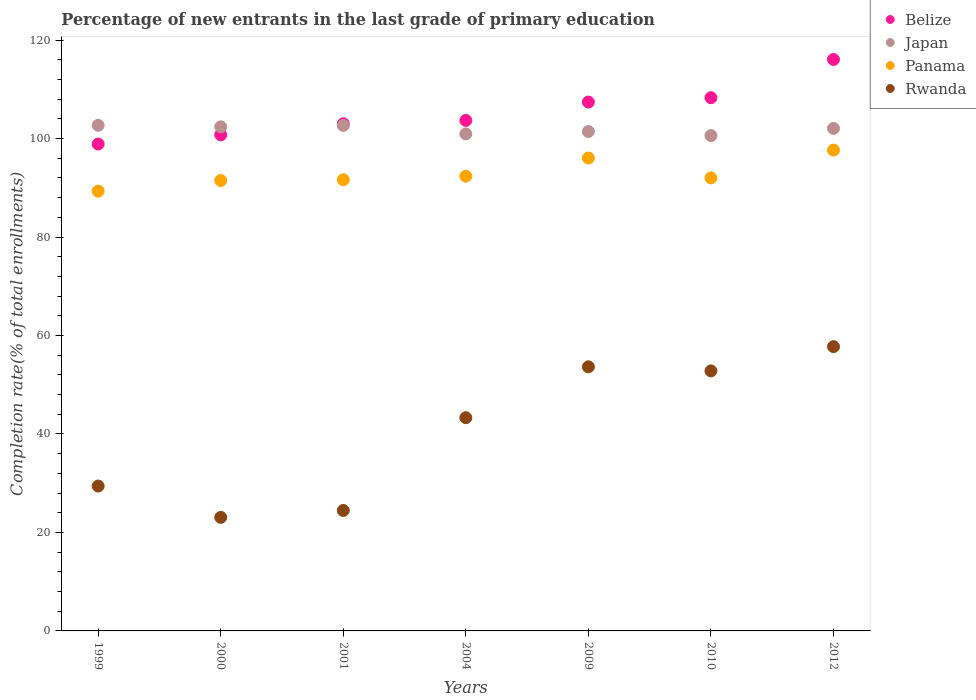What is the percentage of new entrants in Belize in 2009?
Your response must be concise. 107.41. Across all years, what is the maximum percentage of new entrants in Rwanda?
Your response must be concise. 57.74. Across all years, what is the minimum percentage of new entrants in Belize?
Provide a succinct answer. 98.88. In which year was the percentage of new entrants in Rwanda maximum?
Your answer should be compact. 2012. What is the total percentage of new entrants in Rwanda in the graph?
Keep it short and to the point. 284.45. What is the difference between the percentage of new entrants in Rwanda in 1999 and that in 2009?
Give a very brief answer. -24.21. What is the difference between the percentage of new entrants in Panama in 2009 and the percentage of new entrants in Rwanda in 2010?
Give a very brief answer. 43.23. What is the average percentage of new entrants in Rwanda per year?
Ensure brevity in your answer.  40.64. In the year 1999, what is the difference between the percentage of new entrants in Rwanda and percentage of new entrants in Belize?
Your answer should be very brief. -69.46. What is the ratio of the percentage of new entrants in Rwanda in 2000 to that in 2009?
Ensure brevity in your answer.  0.43. Is the difference between the percentage of new entrants in Rwanda in 1999 and 2012 greater than the difference between the percentage of new entrants in Belize in 1999 and 2012?
Make the answer very short. No. What is the difference between the highest and the second highest percentage of new entrants in Belize?
Provide a succinct answer. 7.76. What is the difference between the highest and the lowest percentage of new entrants in Panama?
Provide a succinct answer. 8.34. Is the percentage of new entrants in Rwanda strictly greater than the percentage of new entrants in Belize over the years?
Offer a terse response. No. Are the values on the major ticks of Y-axis written in scientific E-notation?
Ensure brevity in your answer.  No. How many legend labels are there?
Your response must be concise. 4. What is the title of the graph?
Ensure brevity in your answer.  Percentage of new entrants in the last grade of primary education. Does "Morocco" appear as one of the legend labels in the graph?
Your response must be concise. No. What is the label or title of the Y-axis?
Your answer should be very brief. Completion rate(% of total enrollments). What is the Completion rate(% of total enrollments) of Belize in 1999?
Ensure brevity in your answer.  98.88. What is the Completion rate(% of total enrollments) of Japan in 1999?
Ensure brevity in your answer.  102.69. What is the Completion rate(% of total enrollments) in Panama in 1999?
Ensure brevity in your answer.  89.32. What is the Completion rate(% of total enrollments) of Rwanda in 1999?
Offer a terse response. 29.43. What is the Completion rate(% of total enrollments) of Belize in 2000?
Ensure brevity in your answer.  100.76. What is the Completion rate(% of total enrollments) of Japan in 2000?
Your response must be concise. 102.38. What is the Completion rate(% of total enrollments) in Panama in 2000?
Your answer should be compact. 91.48. What is the Completion rate(% of total enrollments) in Rwanda in 2000?
Provide a succinct answer. 23.06. What is the Completion rate(% of total enrollments) of Belize in 2001?
Ensure brevity in your answer.  103. What is the Completion rate(% of total enrollments) in Japan in 2001?
Provide a short and direct response. 102.66. What is the Completion rate(% of total enrollments) in Panama in 2001?
Your answer should be compact. 91.63. What is the Completion rate(% of total enrollments) of Rwanda in 2001?
Provide a short and direct response. 24.47. What is the Completion rate(% of total enrollments) in Belize in 2004?
Offer a very short reply. 103.68. What is the Completion rate(% of total enrollments) of Japan in 2004?
Your answer should be compact. 100.95. What is the Completion rate(% of total enrollments) in Panama in 2004?
Provide a short and direct response. 92.35. What is the Completion rate(% of total enrollments) in Rwanda in 2004?
Your response must be concise. 43.31. What is the Completion rate(% of total enrollments) of Belize in 2009?
Offer a terse response. 107.41. What is the Completion rate(% of total enrollments) of Japan in 2009?
Your answer should be compact. 101.44. What is the Completion rate(% of total enrollments) of Panama in 2009?
Offer a terse response. 96.04. What is the Completion rate(% of total enrollments) of Rwanda in 2009?
Ensure brevity in your answer.  53.64. What is the Completion rate(% of total enrollments) in Belize in 2010?
Ensure brevity in your answer.  108.3. What is the Completion rate(% of total enrollments) of Japan in 2010?
Make the answer very short. 100.6. What is the Completion rate(% of total enrollments) of Panama in 2010?
Provide a short and direct response. 92.01. What is the Completion rate(% of total enrollments) in Rwanda in 2010?
Offer a terse response. 52.81. What is the Completion rate(% of total enrollments) in Belize in 2012?
Keep it short and to the point. 116.06. What is the Completion rate(% of total enrollments) in Japan in 2012?
Provide a succinct answer. 102.06. What is the Completion rate(% of total enrollments) of Panama in 2012?
Provide a succinct answer. 97.66. What is the Completion rate(% of total enrollments) in Rwanda in 2012?
Your answer should be compact. 57.74. Across all years, what is the maximum Completion rate(% of total enrollments) of Belize?
Make the answer very short. 116.06. Across all years, what is the maximum Completion rate(% of total enrollments) of Japan?
Ensure brevity in your answer.  102.69. Across all years, what is the maximum Completion rate(% of total enrollments) of Panama?
Your response must be concise. 97.66. Across all years, what is the maximum Completion rate(% of total enrollments) in Rwanda?
Offer a terse response. 57.74. Across all years, what is the minimum Completion rate(% of total enrollments) of Belize?
Keep it short and to the point. 98.88. Across all years, what is the minimum Completion rate(% of total enrollments) of Japan?
Your response must be concise. 100.6. Across all years, what is the minimum Completion rate(% of total enrollments) in Panama?
Make the answer very short. 89.32. Across all years, what is the minimum Completion rate(% of total enrollments) of Rwanda?
Keep it short and to the point. 23.06. What is the total Completion rate(% of total enrollments) in Belize in the graph?
Offer a very short reply. 738.09. What is the total Completion rate(% of total enrollments) of Japan in the graph?
Give a very brief answer. 712.76. What is the total Completion rate(% of total enrollments) in Panama in the graph?
Make the answer very short. 650.49. What is the total Completion rate(% of total enrollments) of Rwanda in the graph?
Keep it short and to the point. 284.45. What is the difference between the Completion rate(% of total enrollments) in Belize in 1999 and that in 2000?
Keep it short and to the point. -1.87. What is the difference between the Completion rate(% of total enrollments) in Japan in 1999 and that in 2000?
Ensure brevity in your answer.  0.31. What is the difference between the Completion rate(% of total enrollments) of Panama in 1999 and that in 2000?
Your answer should be compact. -2.16. What is the difference between the Completion rate(% of total enrollments) in Rwanda in 1999 and that in 2000?
Offer a very short reply. 6.37. What is the difference between the Completion rate(% of total enrollments) in Belize in 1999 and that in 2001?
Keep it short and to the point. -4.11. What is the difference between the Completion rate(% of total enrollments) of Japan in 1999 and that in 2001?
Your answer should be very brief. 0.03. What is the difference between the Completion rate(% of total enrollments) in Panama in 1999 and that in 2001?
Offer a very short reply. -2.31. What is the difference between the Completion rate(% of total enrollments) in Rwanda in 1999 and that in 2001?
Make the answer very short. 4.96. What is the difference between the Completion rate(% of total enrollments) in Belize in 1999 and that in 2004?
Your response must be concise. -4.79. What is the difference between the Completion rate(% of total enrollments) of Japan in 1999 and that in 2004?
Your response must be concise. 1.74. What is the difference between the Completion rate(% of total enrollments) of Panama in 1999 and that in 2004?
Ensure brevity in your answer.  -3.03. What is the difference between the Completion rate(% of total enrollments) of Rwanda in 1999 and that in 2004?
Make the answer very short. -13.88. What is the difference between the Completion rate(% of total enrollments) in Belize in 1999 and that in 2009?
Your response must be concise. -8.53. What is the difference between the Completion rate(% of total enrollments) in Japan in 1999 and that in 2009?
Give a very brief answer. 1.25. What is the difference between the Completion rate(% of total enrollments) of Panama in 1999 and that in 2009?
Your response must be concise. -6.72. What is the difference between the Completion rate(% of total enrollments) of Rwanda in 1999 and that in 2009?
Your response must be concise. -24.21. What is the difference between the Completion rate(% of total enrollments) in Belize in 1999 and that in 2010?
Your answer should be compact. -9.41. What is the difference between the Completion rate(% of total enrollments) of Japan in 1999 and that in 2010?
Offer a very short reply. 2.09. What is the difference between the Completion rate(% of total enrollments) of Panama in 1999 and that in 2010?
Your answer should be very brief. -2.7. What is the difference between the Completion rate(% of total enrollments) of Rwanda in 1999 and that in 2010?
Make the answer very short. -23.38. What is the difference between the Completion rate(% of total enrollments) in Belize in 1999 and that in 2012?
Your answer should be compact. -17.18. What is the difference between the Completion rate(% of total enrollments) in Japan in 1999 and that in 2012?
Make the answer very short. 0.63. What is the difference between the Completion rate(% of total enrollments) in Panama in 1999 and that in 2012?
Your response must be concise. -8.34. What is the difference between the Completion rate(% of total enrollments) of Rwanda in 1999 and that in 2012?
Make the answer very short. -28.31. What is the difference between the Completion rate(% of total enrollments) of Belize in 2000 and that in 2001?
Your response must be concise. -2.24. What is the difference between the Completion rate(% of total enrollments) in Japan in 2000 and that in 2001?
Give a very brief answer. -0.28. What is the difference between the Completion rate(% of total enrollments) of Panama in 2000 and that in 2001?
Provide a short and direct response. -0.15. What is the difference between the Completion rate(% of total enrollments) of Rwanda in 2000 and that in 2001?
Ensure brevity in your answer.  -1.41. What is the difference between the Completion rate(% of total enrollments) of Belize in 2000 and that in 2004?
Provide a succinct answer. -2.92. What is the difference between the Completion rate(% of total enrollments) in Japan in 2000 and that in 2004?
Give a very brief answer. 1.43. What is the difference between the Completion rate(% of total enrollments) in Panama in 2000 and that in 2004?
Ensure brevity in your answer.  -0.87. What is the difference between the Completion rate(% of total enrollments) in Rwanda in 2000 and that in 2004?
Provide a short and direct response. -20.25. What is the difference between the Completion rate(% of total enrollments) in Belize in 2000 and that in 2009?
Ensure brevity in your answer.  -6.65. What is the difference between the Completion rate(% of total enrollments) of Japan in 2000 and that in 2009?
Your answer should be very brief. 0.94. What is the difference between the Completion rate(% of total enrollments) of Panama in 2000 and that in 2009?
Provide a short and direct response. -4.56. What is the difference between the Completion rate(% of total enrollments) in Rwanda in 2000 and that in 2009?
Provide a succinct answer. -30.58. What is the difference between the Completion rate(% of total enrollments) in Belize in 2000 and that in 2010?
Your response must be concise. -7.54. What is the difference between the Completion rate(% of total enrollments) of Japan in 2000 and that in 2010?
Give a very brief answer. 1.78. What is the difference between the Completion rate(% of total enrollments) in Panama in 2000 and that in 2010?
Ensure brevity in your answer.  -0.54. What is the difference between the Completion rate(% of total enrollments) of Rwanda in 2000 and that in 2010?
Offer a terse response. -29.75. What is the difference between the Completion rate(% of total enrollments) of Belize in 2000 and that in 2012?
Provide a short and direct response. -15.3. What is the difference between the Completion rate(% of total enrollments) in Japan in 2000 and that in 2012?
Make the answer very short. 0.32. What is the difference between the Completion rate(% of total enrollments) of Panama in 2000 and that in 2012?
Give a very brief answer. -6.18. What is the difference between the Completion rate(% of total enrollments) in Rwanda in 2000 and that in 2012?
Provide a short and direct response. -34.68. What is the difference between the Completion rate(% of total enrollments) of Belize in 2001 and that in 2004?
Make the answer very short. -0.68. What is the difference between the Completion rate(% of total enrollments) of Japan in 2001 and that in 2004?
Ensure brevity in your answer.  1.71. What is the difference between the Completion rate(% of total enrollments) in Panama in 2001 and that in 2004?
Provide a succinct answer. -0.72. What is the difference between the Completion rate(% of total enrollments) in Rwanda in 2001 and that in 2004?
Offer a very short reply. -18.84. What is the difference between the Completion rate(% of total enrollments) in Belize in 2001 and that in 2009?
Ensure brevity in your answer.  -4.41. What is the difference between the Completion rate(% of total enrollments) in Japan in 2001 and that in 2009?
Your answer should be compact. 1.22. What is the difference between the Completion rate(% of total enrollments) of Panama in 2001 and that in 2009?
Offer a terse response. -4.41. What is the difference between the Completion rate(% of total enrollments) of Rwanda in 2001 and that in 2009?
Ensure brevity in your answer.  -29.17. What is the difference between the Completion rate(% of total enrollments) in Belize in 2001 and that in 2010?
Your answer should be compact. -5.3. What is the difference between the Completion rate(% of total enrollments) in Japan in 2001 and that in 2010?
Give a very brief answer. 2.06. What is the difference between the Completion rate(% of total enrollments) in Panama in 2001 and that in 2010?
Offer a very short reply. -0.38. What is the difference between the Completion rate(% of total enrollments) in Rwanda in 2001 and that in 2010?
Keep it short and to the point. -28.34. What is the difference between the Completion rate(% of total enrollments) of Belize in 2001 and that in 2012?
Provide a succinct answer. -13.06. What is the difference between the Completion rate(% of total enrollments) in Japan in 2001 and that in 2012?
Your answer should be very brief. 0.6. What is the difference between the Completion rate(% of total enrollments) of Panama in 2001 and that in 2012?
Provide a succinct answer. -6.03. What is the difference between the Completion rate(% of total enrollments) in Rwanda in 2001 and that in 2012?
Your response must be concise. -33.27. What is the difference between the Completion rate(% of total enrollments) of Belize in 2004 and that in 2009?
Offer a terse response. -3.73. What is the difference between the Completion rate(% of total enrollments) of Japan in 2004 and that in 2009?
Provide a succinct answer. -0.49. What is the difference between the Completion rate(% of total enrollments) of Panama in 2004 and that in 2009?
Make the answer very short. -3.69. What is the difference between the Completion rate(% of total enrollments) of Rwanda in 2004 and that in 2009?
Your answer should be very brief. -10.33. What is the difference between the Completion rate(% of total enrollments) in Belize in 2004 and that in 2010?
Make the answer very short. -4.62. What is the difference between the Completion rate(% of total enrollments) in Japan in 2004 and that in 2010?
Make the answer very short. 0.35. What is the difference between the Completion rate(% of total enrollments) in Panama in 2004 and that in 2010?
Provide a succinct answer. 0.34. What is the difference between the Completion rate(% of total enrollments) of Rwanda in 2004 and that in 2010?
Offer a very short reply. -9.5. What is the difference between the Completion rate(% of total enrollments) in Belize in 2004 and that in 2012?
Keep it short and to the point. -12.38. What is the difference between the Completion rate(% of total enrollments) in Japan in 2004 and that in 2012?
Keep it short and to the point. -1.11. What is the difference between the Completion rate(% of total enrollments) of Panama in 2004 and that in 2012?
Your answer should be compact. -5.31. What is the difference between the Completion rate(% of total enrollments) of Rwanda in 2004 and that in 2012?
Give a very brief answer. -14.43. What is the difference between the Completion rate(% of total enrollments) of Belize in 2009 and that in 2010?
Give a very brief answer. -0.89. What is the difference between the Completion rate(% of total enrollments) in Japan in 2009 and that in 2010?
Ensure brevity in your answer.  0.84. What is the difference between the Completion rate(% of total enrollments) in Panama in 2009 and that in 2010?
Give a very brief answer. 4.03. What is the difference between the Completion rate(% of total enrollments) of Rwanda in 2009 and that in 2010?
Offer a very short reply. 0.83. What is the difference between the Completion rate(% of total enrollments) in Belize in 2009 and that in 2012?
Ensure brevity in your answer.  -8.65. What is the difference between the Completion rate(% of total enrollments) in Japan in 2009 and that in 2012?
Offer a very short reply. -0.62. What is the difference between the Completion rate(% of total enrollments) of Panama in 2009 and that in 2012?
Your answer should be very brief. -1.62. What is the difference between the Completion rate(% of total enrollments) in Rwanda in 2009 and that in 2012?
Offer a terse response. -4.1. What is the difference between the Completion rate(% of total enrollments) in Belize in 2010 and that in 2012?
Offer a terse response. -7.76. What is the difference between the Completion rate(% of total enrollments) in Japan in 2010 and that in 2012?
Provide a short and direct response. -1.46. What is the difference between the Completion rate(% of total enrollments) of Panama in 2010 and that in 2012?
Your response must be concise. -5.64. What is the difference between the Completion rate(% of total enrollments) in Rwanda in 2010 and that in 2012?
Provide a succinct answer. -4.93. What is the difference between the Completion rate(% of total enrollments) of Belize in 1999 and the Completion rate(% of total enrollments) of Japan in 2000?
Offer a terse response. -3.5. What is the difference between the Completion rate(% of total enrollments) of Belize in 1999 and the Completion rate(% of total enrollments) of Panama in 2000?
Provide a short and direct response. 7.41. What is the difference between the Completion rate(% of total enrollments) of Belize in 1999 and the Completion rate(% of total enrollments) of Rwanda in 2000?
Make the answer very short. 75.82. What is the difference between the Completion rate(% of total enrollments) of Japan in 1999 and the Completion rate(% of total enrollments) of Panama in 2000?
Keep it short and to the point. 11.21. What is the difference between the Completion rate(% of total enrollments) of Japan in 1999 and the Completion rate(% of total enrollments) of Rwanda in 2000?
Your response must be concise. 79.63. What is the difference between the Completion rate(% of total enrollments) in Panama in 1999 and the Completion rate(% of total enrollments) in Rwanda in 2000?
Keep it short and to the point. 66.26. What is the difference between the Completion rate(% of total enrollments) in Belize in 1999 and the Completion rate(% of total enrollments) in Japan in 2001?
Offer a very short reply. -3.77. What is the difference between the Completion rate(% of total enrollments) in Belize in 1999 and the Completion rate(% of total enrollments) in Panama in 2001?
Offer a terse response. 7.25. What is the difference between the Completion rate(% of total enrollments) in Belize in 1999 and the Completion rate(% of total enrollments) in Rwanda in 2001?
Make the answer very short. 74.42. What is the difference between the Completion rate(% of total enrollments) of Japan in 1999 and the Completion rate(% of total enrollments) of Panama in 2001?
Your answer should be compact. 11.06. What is the difference between the Completion rate(% of total enrollments) of Japan in 1999 and the Completion rate(% of total enrollments) of Rwanda in 2001?
Provide a succinct answer. 78.22. What is the difference between the Completion rate(% of total enrollments) of Panama in 1999 and the Completion rate(% of total enrollments) of Rwanda in 2001?
Offer a very short reply. 64.85. What is the difference between the Completion rate(% of total enrollments) in Belize in 1999 and the Completion rate(% of total enrollments) in Japan in 2004?
Make the answer very short. -2.06. What is the difference between the Completion rate(% of total enrollments) of Belize in 1999 and the Completion rate(% of total enrollments) of Panama in 2004?
Provide a short and direct response. 6.53. What is the difference between the Completion rate(% of total enrollments) in Belize in 1999 and the Completion rate(% of total enrollments) in Rwanda in 2004?
Your answer should be very brief. 55.58. What is the difference between the Completion rate(% of total enrollments) in Japan in 1999 and the Completion rate(% of total enrollments) in Panama in 2004?
Provide a succinct answer. 10.34. What is the difference between the Completion rate(% of total enrollments) in Japan in 1999 and the Completion rate(% of total enrollments) in Rwanda in 2004?
Your response must be concise. 59.38. What is the difference between the Completion rate(% of total enrollments) of Panama in 1999 and the Completion rate(% of total enrollments) of Rwanda in 2004?
Offer a very short reply. 46.01. What is the difference between the Completion rate(% of total enrollments) of Belize in 1999 and the Completion rate(% of total enrollments) of Japan in 2009?
Your answer should be very brief. -2.55. What is the difference between the Completion rate(% of total enrollments) of Belize in 1999 and the Completion rate(% of total enrollments) of Panama in 2009?
Provide a succinct answer. 2.84. What is the difference between the Completion rate(% of total enrollments) of Belize in 1999 and the Completion rate(% of total enrollments) of Rwanda in 2009?
Make the answer very short. 45.25. What is the difference between the Completion rate(% of total enrollments) in Japan in 1999 and the Completion rate(% of total enrollments) in Panama in 2009?
Provide a succinct answer. 6.65. What is the difference between the Completion rate(% of total enrollments) of Japan in 1999 and the Completion rate(% of total enrollments) of Rwanda in 2009?
Offer a terse response. 49.05. What is the difference between the Completion rate(% of total enrollments) of Panama in 1999 and the Completion rate(% of total enrollments) of Rwanda in 2009?
Keep it short and to the point. 35.68. What is the difference between the Completion rate(% of total enrollments) of Belize in 1999 and the Completion rate(% of total enrollments) of Japan in 2010?
Provide a short and direct response. -1.72. What is the difference between the Completion rate(% of total enrollments) in Belize in 1999 and the Completion rate(% of total enrollments) in Panama in 2010?
Keep it short and to the point. 6.87. What is the difference between the Completion rate(% of total enrollments) of Belize in 1999 and the Completion rate(% of total enrollments) of Rwanda in 2010?
Your response must be concise. 46.08. What is the difference between the Completion rate(% of total enrollments) of Japan in 1999 and the Completion rate(% of total enrollments) of Panama in 2010?
Your answer should be compact. 10.67. What is the difference between the Completion rate(% of total enrollments) in Japan in 1999 and the Completion rate(% of total enrollments) in Rwanda in 2010?
Provide a short and direct response. 49.88. What is the difference between the Completion rate(% of total enrollments) of Panama in 1999 and the Completion rate(% of total enrollments) of Rwanda in 2010?
Your response must be concise. 36.51. What is the difference between the Completion rate(% of total enrollments) of Belize in 1999 and the Completion rate(% of total enrollments) of Japan in 2012?
Ensure brevity in your answer.  -3.17. What is the difference between the Completion rate(% of total enrollments) in Belize in 1999 and the Completion rate(% of total enrollments) in Panama in 2012?
Provide a succinct answer. 1.23. What is the difference between the Completion rate(% of total enrollments) of Belize in 1999 and the Completion rate(% of total enrollments) of Rwanda in 2012?
Ensure brevity in your answer.  41.14. What is the difference between the Completion rate(% of total enrollments) in Japan in 1999 and the Completion rate(% of total enrollments) in Panama in 2012?
Your answer should be compact. 5.03. What is the difference between the Completion rate(% of total enrollments) of Japan in 1999 and the Completion rate(% of total enrollments) of Rwanda in 2012?
Ensure brevity in your answer.  44.95. What is the difference between the Completion rate(% of total enrollments) in Panama in 1999 and the Completion rate(% of total enrollments) in Rwanda in 2012?
Ensure brevity in your answer.  31.58. What is the difference between the Completion rate(% of total enrollments) of Belize in 2000 and the Completion rate(% of total enrollments) of Japan in 2001?
Your response must be concise. -1.9. What is the difference between the Completion rate(% of total enrollments) of Belize in 2000 and the Completion rate(% of total enrollments) of Panama in 2001?
Your response must be concise. 9.13. What is the difference between the Completion rate(% of total enrollments) in Belize in 2000 and the Completion rate(% of total enrollments) in Rwanda in 2001?
Offer a terse response. 76.29. What is the difference between the Completion rate(% of total enrollments) of Japan in 2000 and the Completion rate(% of total enrollments) of Panama in 2001?
Your answer should be very brief. 10.75. What is the difference between the Completion rate(% of total enrollments) in Japan in 2000 and the Completion rate(% of total enrollments) in Rwanda in 2001?
Provide a short and direct response. 77.91. What is the difference between the Completion rate(% of total enrollments) in Panama in 2000 and the Completion rate(% of total enrollments) in Rwanda in 2001?
Your answer should be very brief. 67.01. What is the difference between the Completion rate(% of total enrollments) in Belize in 2000 and the Completion rate(% of total enrollments) in Japan in 2004?
Your answer should be compact. -0.19. What is the difference between the Completion rate(% of total enrollments) of Belize in 2000 and the Completion rate(% of total enrollments) of Panama in 2004?
Offer a very short reply. 8.41. What is the difference between the Completion rate(% of total enrollments) in Belize in 2000 and the Completion rate(% of total enrollments) in Rwanda in 2004?
Offer a terse response. 57.45. What is the difference between the Completion rate(% of total enrollments) in Japan in 2000 and the Completion rate(% of total enrollments) in Panama in 2004?
Offer a terse response. 10.03. What is the difference between the Completion rate(% of total enrollments) of Japan in 2000 and the Completion rate(% of total enrollments) of Rwanda in 2004?
Offer a very short reply. 59.07. What is the difference between the Completion rate(% of total enrollments) of Panama in 2000 and the Completion rate(% of total enrollments) of Rwanda in 2004?
Give a very brief answer. 48.17. What is the difference between the Completion rate(% of total enrollments) of Belize in 2000 and the Completion rate(% of total enrollments) of Japan in 2009?
Provide a short and direct response. -0.68. What is the difference between the Completion rate(% of total enrollments) in Belize in 2000 and the Completion rate(% of total enrollments) in Panama in 2009?
Your response must be concise. 4.72. What is the difference between the Completion rate(% of total enrollments) in Belize in 2000 and the Completion rate(% of total enrollments) in Rwanda in 2009?
Provide a short and direct response. 47.12. What is the difference between the Completion rate(% of total enrollments) in Japan in 2000 and the Completion rate(% of total enrollments) in Panama in 2009?
Make the answer very short. 6.34. What is the difference between the Completion rate(% of total enrollments) in Japan in 2000 and the Completion rate(% of total enrollments) in Rwanda in 2009?
Your answer should be very brief. 48.74. What is the difference between the Completion rate(% of total enrollments) of Panama in 2000 and the Completion rate(% of total enrollments) of Rwanda in 2009?
Your response must be concise. 37.84. What is the difference between the Completion rate(% of total enrollments) of Belize in 2000 and the Completion rate(% of total enrollments) of Japan in 2010?
Your answer should be compact. 0.16. What is the difference between the Completion rate(% of total enrollments) in Belize in 2000 and the Completion rate(% of total enrollments) in Panama in 2010?
Your answer should be very brief. 8.74. What is the difference between the Completion rate(% of total enrollments) in Belize in 2000 and the Completion rate(% of total enrollments) in Rwanda in 2010?
Keep it short and to the point. 47.95. What is the difference between the Completion rate(% of total enrollments) of Japan in 2000 and the Completion rate(% of total enrollments) of Panama in 2010?
Ensure brevity in your answer.  10.37. What is the difference between the Completion rate(% of total enrollments) of Japan in 2000 and the Completion rate(% of total enrollments) of Rwanda in 2010?
Make the answer very short. 49.57. What is the difference between the Completion rate(% of total enrollments) in Panama in 2000 and the Completion rate(% of total enrollments) in Rwanda in 2010?
Your answer should be very brief. 38.67. What is the difference between the Completion rate(% of total enrollments) of Belize in 2000 and the Completion rate(% of total enrollments) of Japan in 2012?
Provide a succinct answer. -1.3. What is the difference between the Completion rate(% of total enrollments) of Belize in 2000 and the Completion rate(% of total enrollments) of Panama in 2012?
Provide a succinct answer. 3.1. What is the difference between the Completion rate(% of total enrollments) in Belize in 2000 and the Completion rate(% of total enrollments) in Rwanda in 2012?
Offer a terse response. 43.02. What is the difference between the Completion rate(% of total enrollments) of Japan in 2000 and the Completion rate(% of total enrollments) of Panama in 2012?
Keep it short and to the point. 4.72. What is the difference between the Completion rate(% of total enrollments) in Japan in 2000 and the Completion rate(% of total enrollments) in Rwanda in 2012?
Your response must be concise. 44.64. What is the difference between the Completion rate(% of total enrollments) of Panama in 2000 and the Completion rate(% of total enrollments) of Rwanda in 2012?
Offer a very short reply. 33.74. What is the difference between the Completion rate(% of total enrollments) in Belize in 2001 and the Completion rate(% of total enrollments) in Japan in 2004?
Provide a short and direct response. 2.05. What is the difference between the Completion rate(% of total enrollments) in Belize in 2001 and the Completion rate(% of total enrollments) in Panama in 2004?
Provide a short and direct response. 10.65. What is the difference between the Completion rate(% of total enrollments) of Belize in 2001 and the Completion rate(% of total enrollments) of Rwanda in 2004?
Give a very brief answer. 59.69. What is the difference between the Completion rate(% of total enrollments) of Japan in 2001 and the Completion rate(% of total enrollments) of Panama in 2004?
Ensure brevity in your answer.  10.31. What is the difference between the Completion rate(% of total enrollments) in Japan in 2001 and the Completion rate(% of total enrollments) in Rwanda in 2004?
Provide a succinct answer. 59.35. What is the difference between the Completion rate(% of total enrollments) in Panama in 2001 and the Completion rate(% of total enrollments) in Rwanda in 2004?
Your response must be concise. 48.32. What is the difference between the Completion rate(% of total enrollments) of Belize in 2001 and the Completion rate(% of total enrollments) of Japan in 2009?
Your answer should be very brief. 1.56. What is the difference between the Completion rate(% of total enrollments) in Belize in 2001 and the Completion rate(% of total enrollments) in Panama in 2009?
Make the answer very short. 6.96. What is the difference between the Completion rate(% of total enrollments) in Belize in 2001 and the Completion rate(% of total enrollments) in Rwanda in 2009?
Offer a terse response. 49.36. What is the difference between the Completion rate(% of total enrollments) in Japan in 2001 and the Completion rate(% of total enrollments) in Panama in 2009?
Ensure brevity in your answer.  6.62. What is the difference between the Completion rate(% of total enrollments) in Japan in 2001 and the Completion rate(% of total enrollments) in Rwanda in 2009?
Provide a short and direct response. 49.02. What is the difference between the Completion rate(% of total enrollments) in Panama in 2001 and the Completion rate(% of total enrollments) in Rwanda in 2009?
Offer a very short reply. 37.99. What is the difference between the Completion rate(% of total enrollments) in Belize in 2001 and the Completion rate(% of total enrollments) in Japan in 2010?
Make the answer very short. 2.4. What is the difference between the Completion rate(% of total enrollments) in Belize in 2001 and the Completion rate(% of total enrollments) in Panama in 2010?
Keep it short and to the point. 10.99. What is the difference between the Completion rate(% of total enrollments) of Belize in 2001 and the Completion rate(% of total enrollments) of Rwanda in 2010?
Make the answer very short. 50.19. What is the difference between the Completion rate(% of total enrollments) of Japan in 2001 and the Completion rate(% of total enrollments) of Panama in 2010?
Your answer should be very brief. 10.64. What is the difference between the Completion rate(% of total enrollments) of Japan in 2001 and the Completion rate(% of total enrollments) of Rwanda in 2010?
Your answer should be very brief. 49.85. What is the difference between the Completion rate(% of total enrollments) in Panama in 2001 and the Completion rate(% of total enrollments) in Rwanda in 2010?
Your response must be concise. 38.82. What is the difference between the Completion rate(% of total enrollments) of Belize in 2001 and the Completion rate(% of total enrollments) of Japan in 2012?
Give a very brief answer. 0.94. What is the difference between the Completion rate(% of total enrollments) in Belize in 2001 and the Completion rate(% of total enrollments) in Panama in 2012?
Offer a very short reply. 5.34. What is the difference between the Completion rate(% of total enrollments) of Belize in 2001 and the Completion rate(% of total enrollments) of Rwanda in 2012?
Your answer should be compact. 45.26. What is the difference between the Completion rate(% of total enrollments) of Japan in 2001 and the Completion rate(% of total enrollments) of Panama in 2012?
Your answer should be compact. 5. What is the difference between the Completion rate(% of total enrollments) in Japan in 2001 and the Completion rate(% of total enrollments) in Rwanda in 2012?
Provide a succinct answer. 44.92. What is the difference between the Completion rate(% of total enrollments) in Panama in 2001 and the Completion rate(% of total enrollments) in Rwanda in 2012?
Give a very brief answer. 33.89. What is the difference between the Completion rate(% of total enrollments) in Belize in 2004 and the Completion rate(% of total enrollments) in Japan in 2009?
Make the answer very short. 2.24. What is the difference between the Completion rate(% of total enrollments) in Belize in 2004 and the Completion rate(% of total enrollments) in Panama in 2009?
Provide a short and direct response. 7.64. What is the difference between the Completion rate(% of total enrollments) in Belize in 2004 and the Completion rate(% of total enrollments) in Rwanda in 2009?
Offer a very short reply. 50.04. What is the difference between the Completion rate(% of total enrollments) of Japan in 2004 and the Completion rate(% of total enrollments) of Panama in 2009?
Offer a very short reply. 4.91. What is the difference between the Completion rate(% of total enrollments) of Japan in 2004 and the Completion rate(% of total enrollments) of Rwanda in 2009?
Provide a short and direct response. 47.31. What is the difference between the Completion rate(% of total enrollments) in Panama in 2004 and the Completion rate(% of total enrollments) in Rwanda in 2009?
Keep it short and to the point. 38.71. What is the difference between the Completion rate(% of total enrollments) of Belize in 2004 and the Completion rate(% of total enrollments) of Japan in 2010?
Ensure brevity in your answer.  3.08. What is the difference between the Completion rate(% of total enrollments) of Belize in 2004 and the Completion rate(% of total enrollments) of Panama in 2010?
Give a very brief answer. 11.66. What is the difference between the Completion rate(% of total enrollments) of Belize in 2004 and the Completion rate(% of total enrollments) of Rwanda in 2010?
Provide a short and direct response. 50.87. What is the difference between the Completion rate(% of total enrollments) of Japan in 2004 and the Completion rate(% of total enrollments) of Panama in 2010?
Offer a very short reply. 8.93. What is the difference between the Completion rate(% of total enrollments) in Japan in 2004 and the Completion rate(% of total enrollments) in Rwanda in 2010?
Your answer should be very brief. 48.14. What is the difference between the Completion rate(% of total enrollments) in Panama in 2004 and the Completion rate(% of total enrollments) in Rwanda in 2010?
Ensure brevity in your answer.  39.54. What is the difference between the Completion rate(% of total enrollments) in Belize in 2004 and the Completion rate(% of total enrollments) in Japan in 2012?
Offer a very short reply. 1.62. What is the difference between the Completion rate(% of total enrollments) of Belize in 2004 and the Completion rate(% of total enrollments) of Panama in 2012?
Your answer should be compact. 6.02. What is the difference between the Completion rate(% of total enrollments) in Belize in 2004 and the Completion rate(% of total enrollments) in Rwanda in 2012?
Provide a succinct answer. 45.94. What is the difference between the Completion rate(% of total enrollments) in Japan in 2004 and the Completion rate(% of total enrollments) in Panama in 2012?
Offer a very short reply. 3.29. What is the difference between the Completion rate(% of total enrollments) of Japan in 2004 and the Completion rate(% of total enrollments) of Rwanda in 2012?
Your answer should be compact. 43.21. What is the difference between the Completion rate(% of total enrollments) of Panama in 2004 and the Completion rate(% of total enrollments) of Rwanda in 2012?
Ensure brevity in your answer.  34.61. What is the difference between the Completion rate(% of total enrollments) in Belize in 2009 and the Completion rate(% of total enrollments) in Japan in 2010?
Your response must be concise. 6.81. What is the difference between the Completion rate(% of total enrollments) in Belize in 2009 and the Completion rate(% of total enrollments) in Panama in 2010?
Keep it short and to the point. 15.4. What is the difference between the Completion rate(% of total enrollments) in Belize in 2009 and the Completion rate(% of total enrollments) in Rwanda in 2010?
Make the answer very short. 54.6. What is the difference between the Completion rate(% of total enrollments) in Japan in 2009 and the Completion rate(% of total enrollments) in Panama in 2010?
Give a very brief answer. 9.42. What is the difference between the Completion rate(% of total enrollments) of Japan in 2009 and the Completion rate(% of total enrollments) of Rwanda in 2010?
Your answer should be very brief. 48.63. What is the difference between the Completion rate(% of total enrollments) in Panama in 2009 and the Completion rate(% of total enrollments) in Rwanda in 2010?
Offer a very short reply. 43.23. What is the difference between the Completion rate(% of total enrollments) of Belize in 2009 and the Completion rate(% of total enrollments) of Japan in 2012?
Ensure brevity in your answer.  5.35. What is the difference between the Completion rate(% of total enrollments) in Belize in 2009 and the Completion rate(% of total enrollments) in Panama in 2012?
Your answer should be very brief. 9.75. What is the difference between the Completion rate(% of total enrollments) of Belize in 2009 and the Completion rate(% of total enrollments) of Rwanda in 2012?
Provide a succinct answer. 49.67. What is the difference between the Completion rate(% of total enrollments) of Japan in 2009 and the Completion rate(% of total enrollments) of Panama in 2012?
Offer a very short reply. 3.78. What is the difference between the Completion rate(% of total enrollments) of Japan in 2009 and the Completion rate(% of total enrollments) of Rwanda in 2012?
Give a very brief answer. 43.7. What is the difference between the Completion rate(% of total enrollments) of Panama in 2009 and the Completion rate(% of total enrollments) of Rwanda in 2012?
Make the answer very short. 38.3. What is the difference between the Completion rate(% of total enrollments) in Belize in 2010 and the Completion rate(% of total enrollments) in Japan in 2012?
Provide a succinct answer. 6.24. What is the difference between the Completion rate(% of total enrollments) in Belize in 2010 and the Completion rate(% of total enrollments) in Panama in 2012?
Your response must be concise. 10.64. What is the difference between the Completion rate(% of total enrollments) of Belize in 2010 and the Completion rate(% of total enrollments) of Rwanda in 2012?
Provide a short and direct response. 50.56. What is the difference between the Completion rate(% of total enrollments) of Japan in 2010 and the Completion rate(% of total enrollments) of Panama in 2012?
Keep it short and to the point. 2.94. What is the difference between the Completion rate(% of total enrollments) of Japan in 2010 and the Completion rate(% of total enrollments) of Rwanda in 2012?
Your answer should be compact. 42.86. What is the difference between the Completion rate(% of total enrollments) in Panama in 2010 and the Completion rate(% of total enrollments) in Rwanda in 2012?
Give a very brief answer. 34.27. What is the average Completion rate(% of total enrollments) of Belize per year?
Make the answer very short. 105.44. What is the average Completion rate(% of total enrollments) in Japan per year?
Your response must be concise. 101.82. What is the average Completion rate(% of total enrollments) in Panama per year?
Offer a very short reply. 92.93. What is the average Completion rate(% of total enrollments) in Rwanda per year?
Provide a short and direct response. 40.64. In the year 1999, what is the difference between the Completion rate(% of total enrollments) of Belize and Completion rate(% of total enrollments) of Japan?
Keep it short and to the point. -3.8. In the year 1999, what is the difference between the Completion rate(% of total enrollments) in Belize and Completion rate(% of total enrollments) in Panama?
Offer a terse response. 9.57. In the year 1999, what is the difference between the Completion rate(% of total enrollments) of Belize and Completion rate(% of total enrollments) of Rwanda?
Your answer should be very brief. 69.46. In the year 1999, what is the difference between the Completion rate(% of total enrollments) in Japan and Completion rate(% of total enrollments) in Panama?
Ensure brevity in your answer.  13.37. In the year 1999, what is the difference between the Completion rate(% of total enrollments) of Japan and Completion rate(% of total enrollments) of Rwanda?
Keep it short and to the point. 73.26. In the year 1999, what is the difference between the Completion rate(% of total enrollments) in Panama and Completion rate(% of total enrollments) in Rwanda?
Ensure brevity in your answer.  59.89. In the year 2000, what is the difference between the Completion rate(% of total enrollments) of Belize and Completion rate(% of total enrollments) of Japan?
Your answer should be very brief. -1.62. In the year 2000, what is the difference between the Completion rate(% of total enrollments) in Belize and Completion rate(% of total enrollments) in Panama?
Provide a succinct answer. 9.28. In the year 2000, what is the difference between the Completion rate(% of total enrollments) in Belize and Completion rate(% of total enrollments) in Rwanda?
Your answer should be very brief. 77.7. In the year 2000, what is the difference between the Completion rate(% of total enrollments) of Japan and Completion rate(% of total enrollments) of Panama?
Offer a terse response. 10.9. In the year 2000, what is the difference between the Completion rate(% of total enrollments) in Japan and Completion rate(% of total enrollments) in Rwanda?
Keep it short and to the point. 79.32. In the year 2000, what is the difference between the Completion rate(% of total enrollments) of Panama and Completion rate(% of total enrollments) of Rwanda?
Ensure brevity in your answer.  68.42. In the year 2001, what is the difference between the Completion rate(% of total enrollments) of Belize and Completion rate(% of total enrollments) of Japan?
Offer a very short reply. 0.34. In the year 2001, what is the difference between the Completion rate(% of total enrollments) of Belize and Completion rate(% of total enrollments) of Panama?
Your response must be concise. 11.37. In the year 2001, what is the difference between the Completion rate(% of total enrollments) in Belize and Completion rate(% of total enrollments) in Rwanda?
Your answer should be compact. 78.53. In the year 2001, what is the difference between the Completion rate(% of total enrollments) in Japan and Completion rate(% of total enrollments) in Panama?
Your answer should be compact. 11.03. In the year 2001, what is the difference between the Completion rate(% of total enrollments) of Japan and Completion rate(% of total enrollments) of Rwanda?
Make the answer very short. 78.19. In the year 2001, what is the difference between the Completion rate(% of total enrollments) in Panama and Completion rate(% of total enrollments) in Rwanda?
Your answer should be compact. 67.16. In the year 2004, what is the difference between the Completion rate(% of total enrollments) in Belize and Completion rate(% of total enrollments) in Japan?
Your response must be concise. 2.73. In the year 2004, what is the difference between the Completion rate(% of total enrollments) in Belize and Completion rate(% of total enrollments) in Panama?
Offer a terse response. 11.33. In the year 2004, what is the difference between the Completion rate(% of total enrollments) in Belize and Completion rate(% of total enrollments) in Rwanda?
Provide a succinct answer. 60.37. In the year 2004, what is the difference between the Completion rate(% of total enrollments) of Japan and Completion rate(% of total enrollments) of Panama?
Ensure brevity in your answer.  8.59. In the year 2004, what is the difference between the Completion rate(% of total enrollments) in Japan and Completion rate(% of total enrollments) in Rwanda?
Offer a very short reply. 57.64. In the year 2004, what is the difference between the Completion rate(% of total enrollments) in Panama and Completion rate(% of total enrollments) in Rwanda?
Offer a very short reply. 49.04. In the year 2009, what is the difference between the Completion rate(% of total enrollments) of Belize and Completion rate(% of total enrollments) of Japan?
Provide a short and direct response. 5.97. In the year 2009, what is the difference between the Completion rate(% of total enrollments) of Belize and Completion rate(% of total enrollments) of Panama?
Offer a terse response. 11.37. In the year 2009, what is the difference between the Completion rate(% of total enrollments) of Belize and Completion rate(% of total enrollments) of Rwanda?
Keep it short and to the point. 53.77. In the year 2009, what is the difference between the Completion rate(% of total enrollments) in Japan and Completion rate(% of total enrollments) in Panama?
Provide a succinct answer. 5.4. In the year 2009, what is the difference between the Completion rate(% of total enrollments) in Japan and Completion rate(% of total enrollments) in Rwanda?
Provide a succinct answer. 47.8. In the year 2009, what is the difference between the Completion rate(% of total enrollments) in Panama and Completion rate(% of total enrollments) in Rwanda?
Keep it short and to the point. 42.4. In the year 2010, what is the difference between the Completion rate(% of total enrollments) of Belize and Completion rate(% of total enrollments) of Japan?
Provide a succinct answer. 7.7. In the year 2010, what is the difference between the Completion rate(% of total enrollments) of Belize and Completion rate(% of total enrollments) of Panama?
Offer a terse response. 16.28. In the year 2010, what is the difference between the Completion rate(% of total enrollments) in Belize and Completion rate(% of total enrollments) in Rwanda?
Offer a terse response. 55.49. In the year 2010, what is the difference between the Completion rate(% of total enrollments) of Japan and Completion rate(% of total enrollments) of Panama?
Provide a short and direct response. 8.59. In the year 2010, what is the difference between the Completion rate(% of total enrollments) in Japan and Completion rate(% of total enrollments) in Rwanda?
Your response must be concise. 47.79. In the year 2010, what is the difference between the Completion rate(% of total enrollments) in Panama and Completion rate(% of total enrollments) in Rwanda?
Keep it short and to the point. 39.21. In the year 2012, what is the difference between the Completion rate(% of total enrollments) of Belize and Completion rate(% of total enrollments) of Japan?
Your answer should be very brief. 14. In the year 2012, what is the difference between the Completion rate(% of total enrollments) in Belize and Completion rate(% of total enrollments) in Panama?
Give a very brief answer. 18.4. In the year 2012, what is the difference between the Completion rate(% of total enrollments) of Belize and Completion rate(% of total enrollments) of Rwanda?
Offer a terse response. 58.32. In the year 2012, what is the difference between the Completion rate(% of total enrollments) in Japan and Completion rate(% of total enrollments) in Panama?
Keep it short and to the point. 4.4. In the year 2012, what is the difference between the Completion rate(% of total enrollments) in Japan and Completion rate(% of total enrollments) in Rwanda?
Your answer should be very brief. 44.32. In the year 2012, what is the difference between the Completion rate(% of total enrollments) in Panama and Completion rate(% of total enrollments) in Rwanda?
Provide a succinct answer. 39.92. What is the ratio of the Completion rate(% of total enrollments) of Belize in 1999 to that in 2000?
Ensure brevity in your answer.  0.98. What is the ratio of the Completion rate(% of total enrollments) in Panama in 1999 to that in 2000?
Your response must be concise. 0.98. What is the ratio of the Completion rate(% of total enrollments) of Rwanda in 1999 to that in 2000?
Your answer should be very brief. 1.28. What is the ratio of the Completion rate(% of total enrollments) of Belize in 1999 to that in 2001?
Ensure brevity in your answer.  0.96. What is the ratio of the Completion rate(% of total enrollments) in Japan in 1999 to that in 2001?
Your answer should be compact. 1. What is the ratio of the Completion rate(% of total enrollments) of Panama in 1999 to that in 2001?
Ensure brevity in your answer.  0.97. What is the ratio of the Completion rate(% of total enrollments) of Rwanda in 1999 to that in 2001?
Ensure brevity in your answer.  1.2. What is the ratio of the Completion rate(% of total enrollments) of Belize in 1999 to that in 2004?
Provide a succinct answer. 0.95. What is the ratio of the Completion rate(% of total enrollments) of Japan in 1999 to that in 2004?
Ensure brevity in your answer.  1.02. What is the ratio of the Completion rate(% of total enrollments) of Panama in 1999 to that in 2004?
Offer a very short reply. 0.97. What is the ratio of the Completion rate(% of total enrollments) in Rwanda in 1999 to that in 2004?
Offer a very short reply. 0.68. What is the ratio of the Completion rate(% of total enrollments) of Belize in 1999 to that in 2009?
Give a very brief answer. 0.92. What is the ratio of the Completion rate(% of total enrollments) in Japan in 1999 to that in 2009?
Keep it short and to the point. 1.01. What is the ratio of the Completion rate(% of total enrollments) of Rwanda in 1999 to that in 2009?
Your answer should be compact. 0.55. What is the ratio of the Completion rate(% of total enrollments) in Belize in 1999 to that in 2010?
Your answer should be compact. 0.91. What is the ratio of the Completion rate(% of total enrollments) in Japan in 1999 to that in 2010?
Keep it short and to the point. 1.02. What is the ratio of the Completion rate(% of total enrollments) of Panama in 1999 to that in 2010?
Offer a very short reply. 0.97. What is the ratio of the Completion rate(% of total enrollments) in Rwanda in 1999 to that in 2010?
Your answer should be compact. 0.56. What is the ratio of the Completion rate(% of total enrollments) in Belize in 1999 to that in 2012?
Offer a very short reply. 0.85. What is the ratio of the Completion rate(% of total enrollments) of Japan in 1999 to that in 2012?
Your answer should be very brief. 1.01. What is the ratio of the Completion rate(% of total enrollments) of Panama in 1999 to that in 2012?
Provide a succinct answer. 0.91. What is the ratio of the Completion rate(% of total enrollments) of Rwanda in 1999 to that in 2012?
Your answer should be very brief. 0.51. What is the ratio of the Completion rate(% of total enrollments) in Belize in 2000 to that in 2001?
Offer a very short reply. 0.98. What is the ratio of the Completion rate(% of total enrollments) of Japan in 2000 to that in 2001?
Provide a short and direct response. 1. What is the ratio of the Completion rate(% of total enrollments) in Panama in 2000 to that in 2001?
Give a very brief answer. 1. What is the ratio of the Completion rate(% of total enrollments) of Rwanda in 2000 to that in 2001?
Your answer should be compact. 0.94. What is the ratio of the Completion rate(% of total enrollments) in Belize in 2000 to that in 2004?
Make the answer very short. 0.97. What is the ratio of the Completion rate(% of total enrollments) in Japan in 2000 to that in 2004?
Offer a very short reply. 1.01. What is the ratio of the Completion rate(% of total enrollments) in Rwanda in 2000 to that in 2004?
Offer a terse response. 0.53. What is the ratio of the Completion rate(% of total enrollments) in Belize in 2000 to that in 2009?
Provide a short and direct response. 0.94. What is the ratio of the Completion rate(% of total enrollments) of Japan in 2000 to that in 2009?
Your response must be concise. 1.01. What is the ratio of the Completion rate(% of total enrollments) in Panama in 2000 to that in 2009?
Make the answer very short. 0.95. What is the ratio of the Completion rate(% of total enrollments) in Rwanda in 2000 to that in 2009?
Offer a very short reply. 0.43. What is the ratio of the Completion rate(% of total enrollments) of Belize in 2000 to that in 2010?
Give a very brief answer. 0.93. What is the ratio of the Completion rate(% of total enrollments) of Japan in 2000 to that in 2010?
Keep it short and to the point. 1.02. What is the ratio of the Completion rate(% of total enrollments) of Panama in 2000 to that in 2010?
Keep it short and to the point. 0.99. What is the ratio of the Completion rate(% of total enrollments) of Rwanda in 2000 to that in 2010?
Your answer should be very brief. 0.44. What is the ratio of the Completion rate(% of total enrollments) of Belize in 2000 to that in 2012?
Your answer should be compact. 0.87. What is the ratio of the Completion rate(% of total enrollments) of Japan in 2000 to that in 2012?
Offer a terse response. 1. What is the ratio of the Completion rate(% of total enrollments) of Panama in 2000 to that in 2012?
Make the answer very short. 0.94. What is the ratio of the Completion rate(% of total enrollments) in Rwanda in 2000 to that in 2012?
Your response must be concise. 0.4. What is the ratio of the Completion rate(% of total enrollments) of Japan in 2001 to that in 2004?
Provide a succinct answer. 1.02. What is the ratio of the Completion rate(% of total enrollments) in Rwanda in 2001 to that in 2004?
Your answer should be very brief. 0.56. What is the ratio of the Completion rate(% of total enrollments) of Belize in 2001 to that in 2009?
Your answer should be very brief. 0.96. What is the ratio of the Completion rate(% of total enrollments) of Japan in 2001 to that in 2009?
Provide a short and direct response. 1.01. What is the ratio of the Completion rate(% of total enrollments) in Panama in 2001 to that in 2009?
Provide a succinct answer. 0.95. What is the ratio of the Completion rate(% of total enrollments) of Rwanda in 2001 to that in 2009?
Provide a succinct answer. 0.46. What is the ratio of the Completion rate(% of total enrollments) in Belize in 2001 to that in 2010?
Make the answer very short. 0.95. What is the ratio of the Completion rate(% of total enrollments) of Japan in 2001 to that in 2010?
Provide a succinct answer. 1.02. What is the ratio of the Completion rate(% of total enrollments) in Rwanda in 2001 to that in 2010?
Give a very brief answer. 0.46. What is the ratio of the Completion rate(% of total enrollments) in Belize in 2001 to that in 2012?
Your answer should be very brief. 0.89. What is the ratio of the Completion rate(% of total enrollments) of Japan in 2001 to that in 2012?
Provide a succinct answer. 1.01. What is the ratio of the Completion rate(% of total enrollments) in Panama in 2001 to that in 2012?
Your answer should be compact. 0.94. What is the ratio of the Completion rate(% of total enrollments) of Rwanda in 2001 to that in 2012?
Offer a very short reply. 0.42. What is the ratio of the Completion rate(% of total enrollments) in Belize in 2004 to that in 2009?
Make the answer very short. 0.97. What is the ratio of the Completion rate(% of total enrollments) in Panama in 2004 to that in 2009?
Make the answer very short. 0.96. What is the ratio of the Completion rate(% of total enrollments) of Rwanda in 2004 to that in 2009?
Make the answer very short. 0.81. What is the ratio of the Completion rate(% of total enrollments) of Belize in 2004 to that in 2010?
Offer a terse response. 0.96. What is the ratio of the Completion rate(% of total enrollments) of Panama in 2004 to that in 2010?
Give a very brief answer. 1. What is the ratio of the Completion rate(% of total enrollments) of Rwanda in 2004 to that in 2010?
Your answer should be compact. 0.82. What is the ratio of the Completion rate(% of total enrollments) in Belize in 2004 to that in 2012?
Make the answer very short. 0.89. What is the ratio of the Completion rate(% of total enrollments) of Japan in 2004 to that in 2012?
Your answer should be very brief. 0.99. What is the ratio of the Completion rate(% of total enrollments) in Panama in 2004 to that in 2012?
Your answer should be very brief. 0.95. What is the ratio of the Completion rate(% of total enrollments) in Rwanda in 2004 to that in 2012?
Your answer should be compact. 0.75. What is the ratio of the Completion rate(% of total enrollments) in Japan in 2009 to that in 2010?
Give a very brief answer. 1.01. What is the ratio of the Completion rate(% of total enrollments) in Panama in 2009 to that in 2010?
Provide a succinct answer. 1.04. What is the ratio of the Completion rate(% of total enrollments) in Rwanda in 2009 to that in 2010?
Offer a very short reply. 1.02. What is the ratio of the Completion rate(% of total enrollments) in Belize in 2009 to that in 2012?
Ensure brevity in your answer.  0.93. What is the ratio of the Completion rate(% of total enrollments) in Japan in 2009 to that in 2012?
Keep it short and to the point. 0.99. What is the ratio of the Completion rate(% of total enrollments) in Panama in 2009 to that in 2012?
Provide a short and direct response. 0.98. What is the ratio of the Completion rate(% of total enrollments) of Rwanda in 2009 to that in 2012?
Provide a succinct answer. 0.93. What is the ratio of the Completion rate(% of total enrollments) of Belize in 2010 to that in 2012?
Your answer should be very brief. 0.93. What is the ratio of the Completion rate(% of total enrollments) in Japan in 2010 to that in 2012?
Offer a terse response. 0.99. What is the ratio of the Completion rate(% of total enrollments) in Panama in 2010 to that in 2012?
Offer a very short reply. 0.94. What is the ratio of the Completion rate(% of total enrollments) of Rwanda in 2010 to that in 2012?
Offer a terse response. 0.91. What is the difference between the highest and the second highest Completion rate(% of total enrollments) in Belize?
Give a very brief answer. 7.76. What is the difference between the highest and the second highest Completion rate(% of total enrollments) of Japan?
Keep it short and to the point. 0.03. What is the difference between the highest and the second highest Completion rate(% of total enrollments) of Panama?
Your answer should be compact. 1.62. What is the difference between the highest and the second highest Completion rate(% of total enrollments) in Rwanda?
Make the answer very short. 4.1. What is the difference between the highest and the lowest Completion rate(% of total enrollments) of Belize?
Your answer should be very brief. 17.18. What is the difference between the highest and the lowest Completion rate(% of total enrollments) in Japan?
Your response must be concise. 2.09. What is the difference between the highest and the lowest Completion rate(% of total enrollments) of Panama?
Provide a succinct answer. 8.34. What is the difference between the highest and the lowest Completion rate(% of total enrollments) of Rwanda?
Your response must be concise. 34.68. 